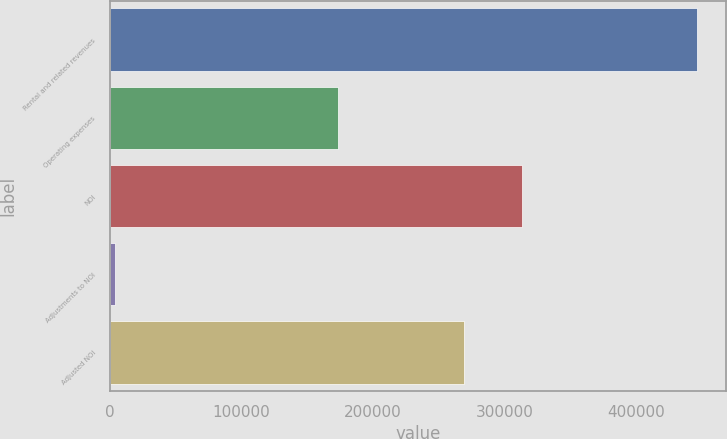Convert chart. <chart><loc_0><loc_0><loc_500><loc_500><bar_chart><fcel>Rental and related revenues<fcel>Operating expenses<fcel>NOI<fcel>Adjustments to NOI<fcel>Adjusted NOI<nl><fcel>446280<fcel>173687<fcel>313331<fcel>3536<fcel>269057<nl></chart> 